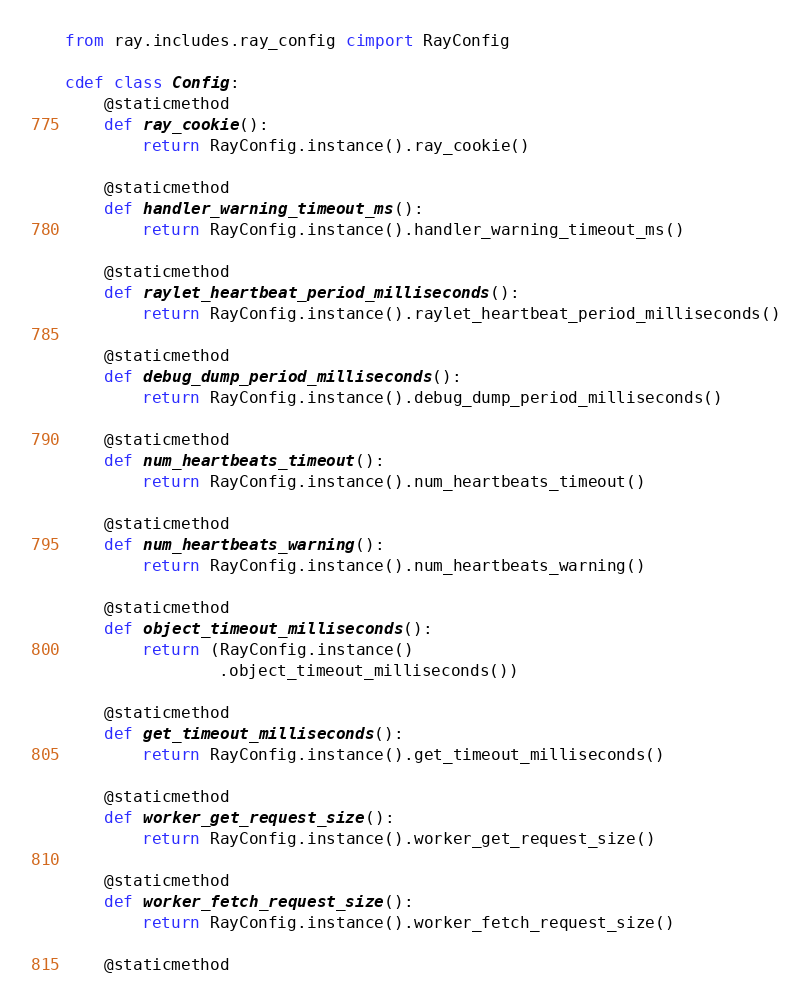Convert code to text. <code><loc_0><loc_0><loc_500><loc_500><_Cython_>from ray.includes.ray_config cimport RayConfig

cdef class Config:
    @staticmethod
    def ray_cookie():
        return RayConfig.instance().ray_cookie()

    @staticmethod
    def handler_warning_timeout_ms():
        return RayConfig.instance().handler_warning_timeout_ms()

    @staticmethod
    def raylet_heartbeat_period_milliseconds():
        return RayConfig.instance().raylet_heartbeat_period_milliseconds()

    @staticmethod
    def debug_dump_period_milliseconds():
        return RayConfig.instance().debug_dump_period_milliseconds()

    @staticmethod
    def num_heartbeats_timeout():
        return RayConfig.instance().num_heartbeats_timeout()

    @staticmethod
    def num_heartbeats_warning():
        return RayConfig.instance().num_heartbeats_warning()

    @staticmethod
    def object_timeout_milliseconds():
        return (RayConfig.instance()
                .object_timeout_milliseconds())

    @staticmethod
    def get_timeout_milliseconds():
        return RayConfig.instance().get_timeout_milliseconds()

    @staticmethod
    def worker_get_request_size():
        return RayConfig.instance().worker_get_request_size()

    @staticmethod
    def worker_fetch_request_size():
        return RayConfig.instance().worker_fetch_request_size()

    @staticmethod</code> 